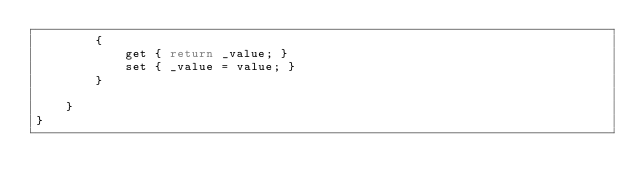<code> <loc_0><loc_0><loc_500><loc_500><_C#_>        {
            get { return _value; }
            set { _value = value; }
        }

    }
}
</code> 